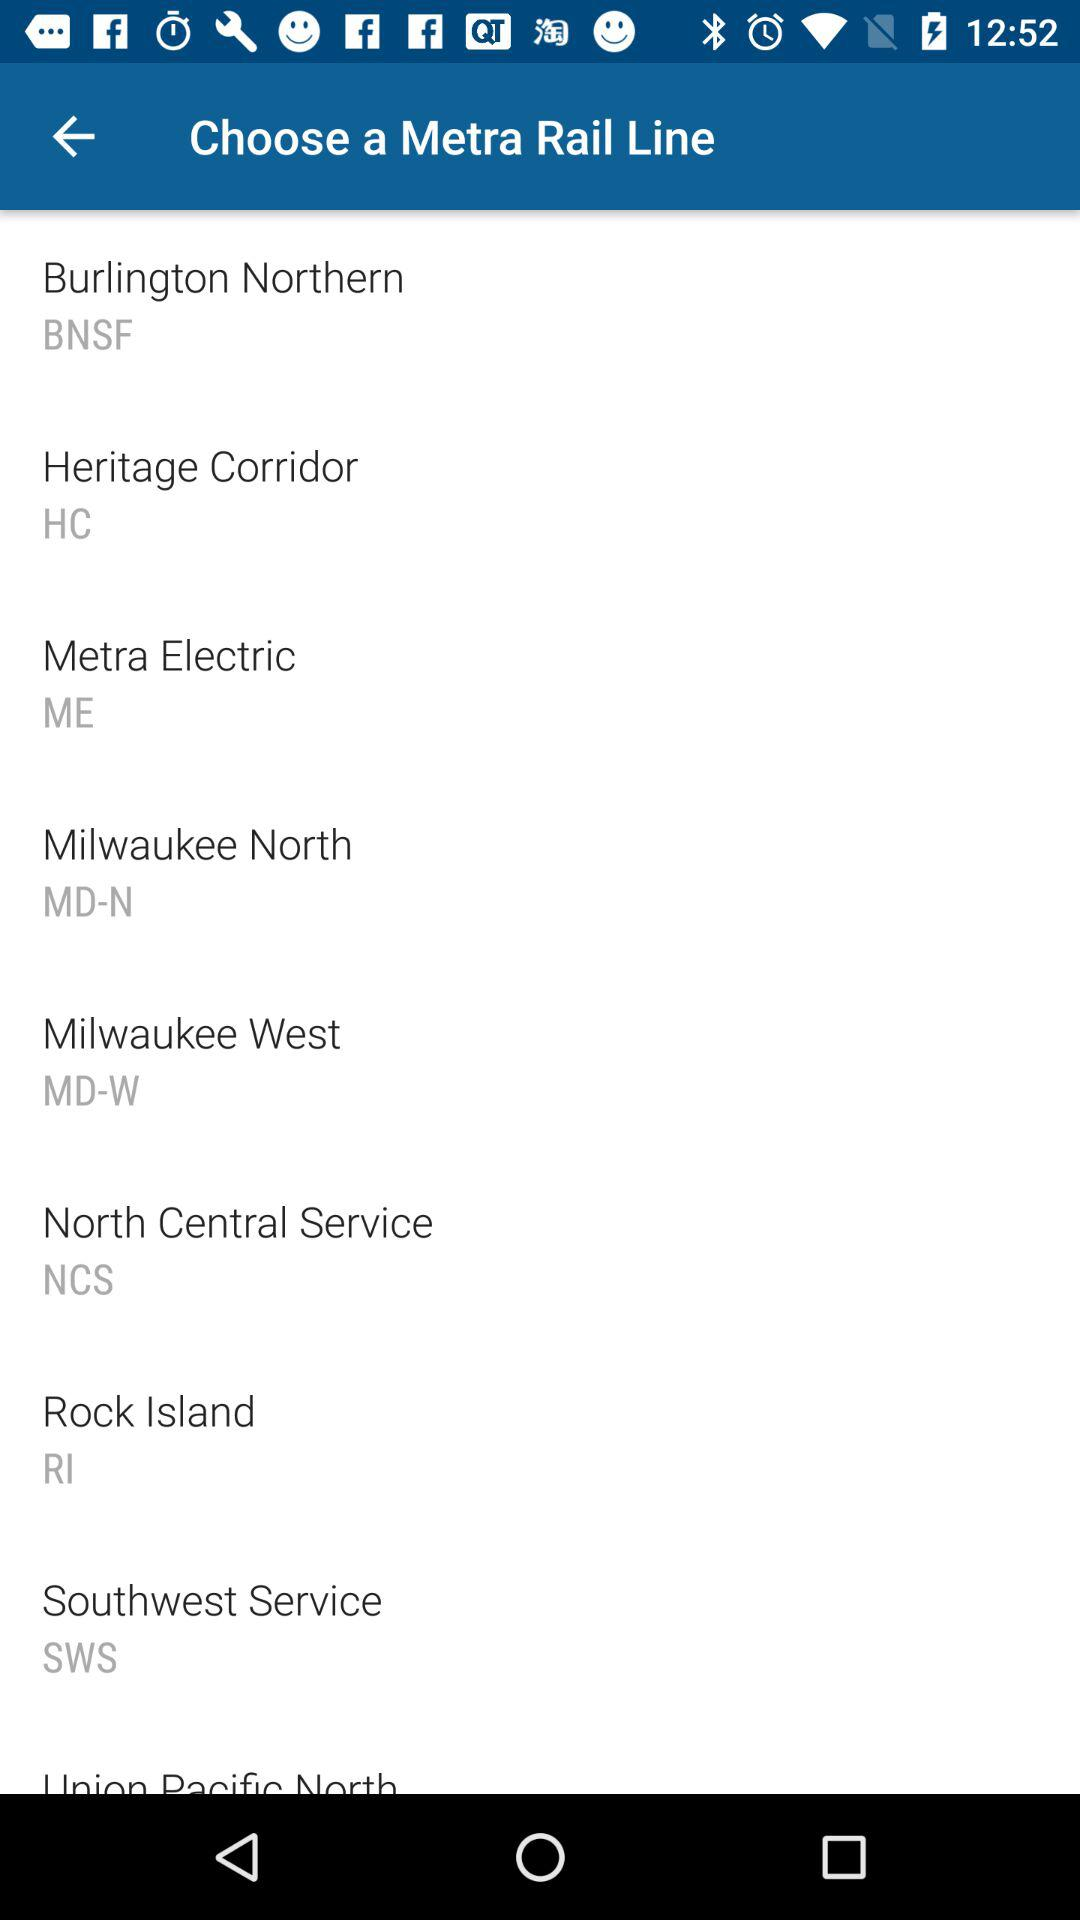What's the Burlington Northern Metra rail line code? The code is "BNSF". 